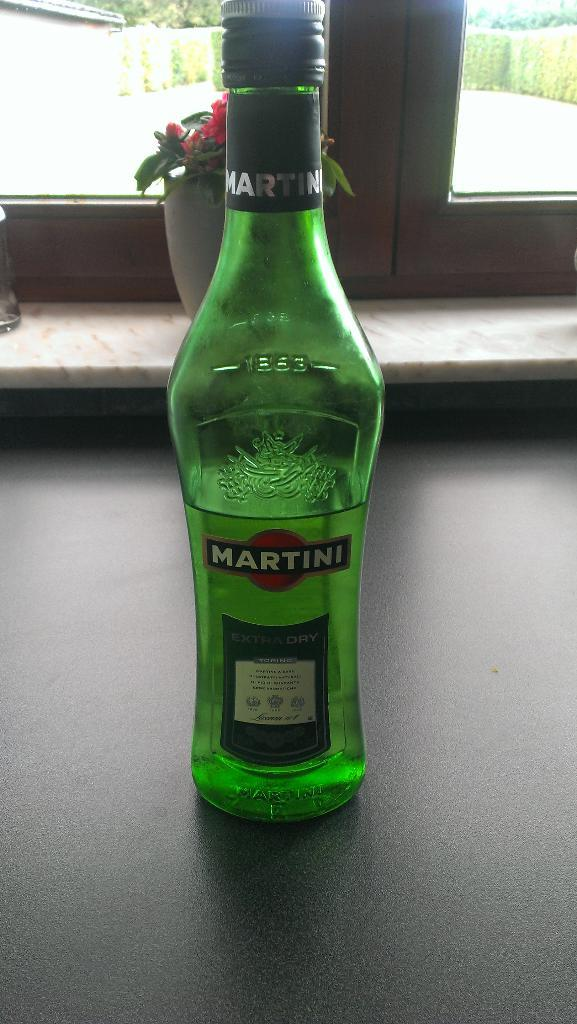<image>
Relay a brief, clear account of the picture shown. A bottle of Martini extra dry is on a table. 